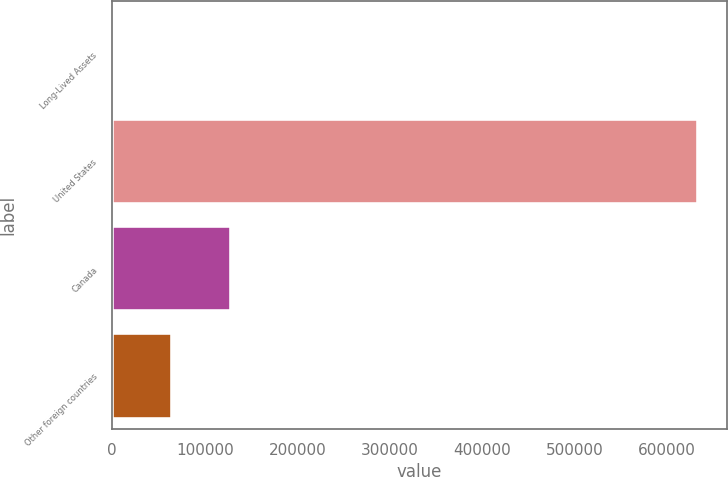Convert chart. <chart><loc_0><loc_0><loc_500><loc_500><bar_chart><fcel>Long-Lived Assets<fcel>United States<fcel>Canada<fcel>Other foreign countries<nl><fcel>2013<fcel>632783<fcel>128167<fcel>65090<nl></chart> 